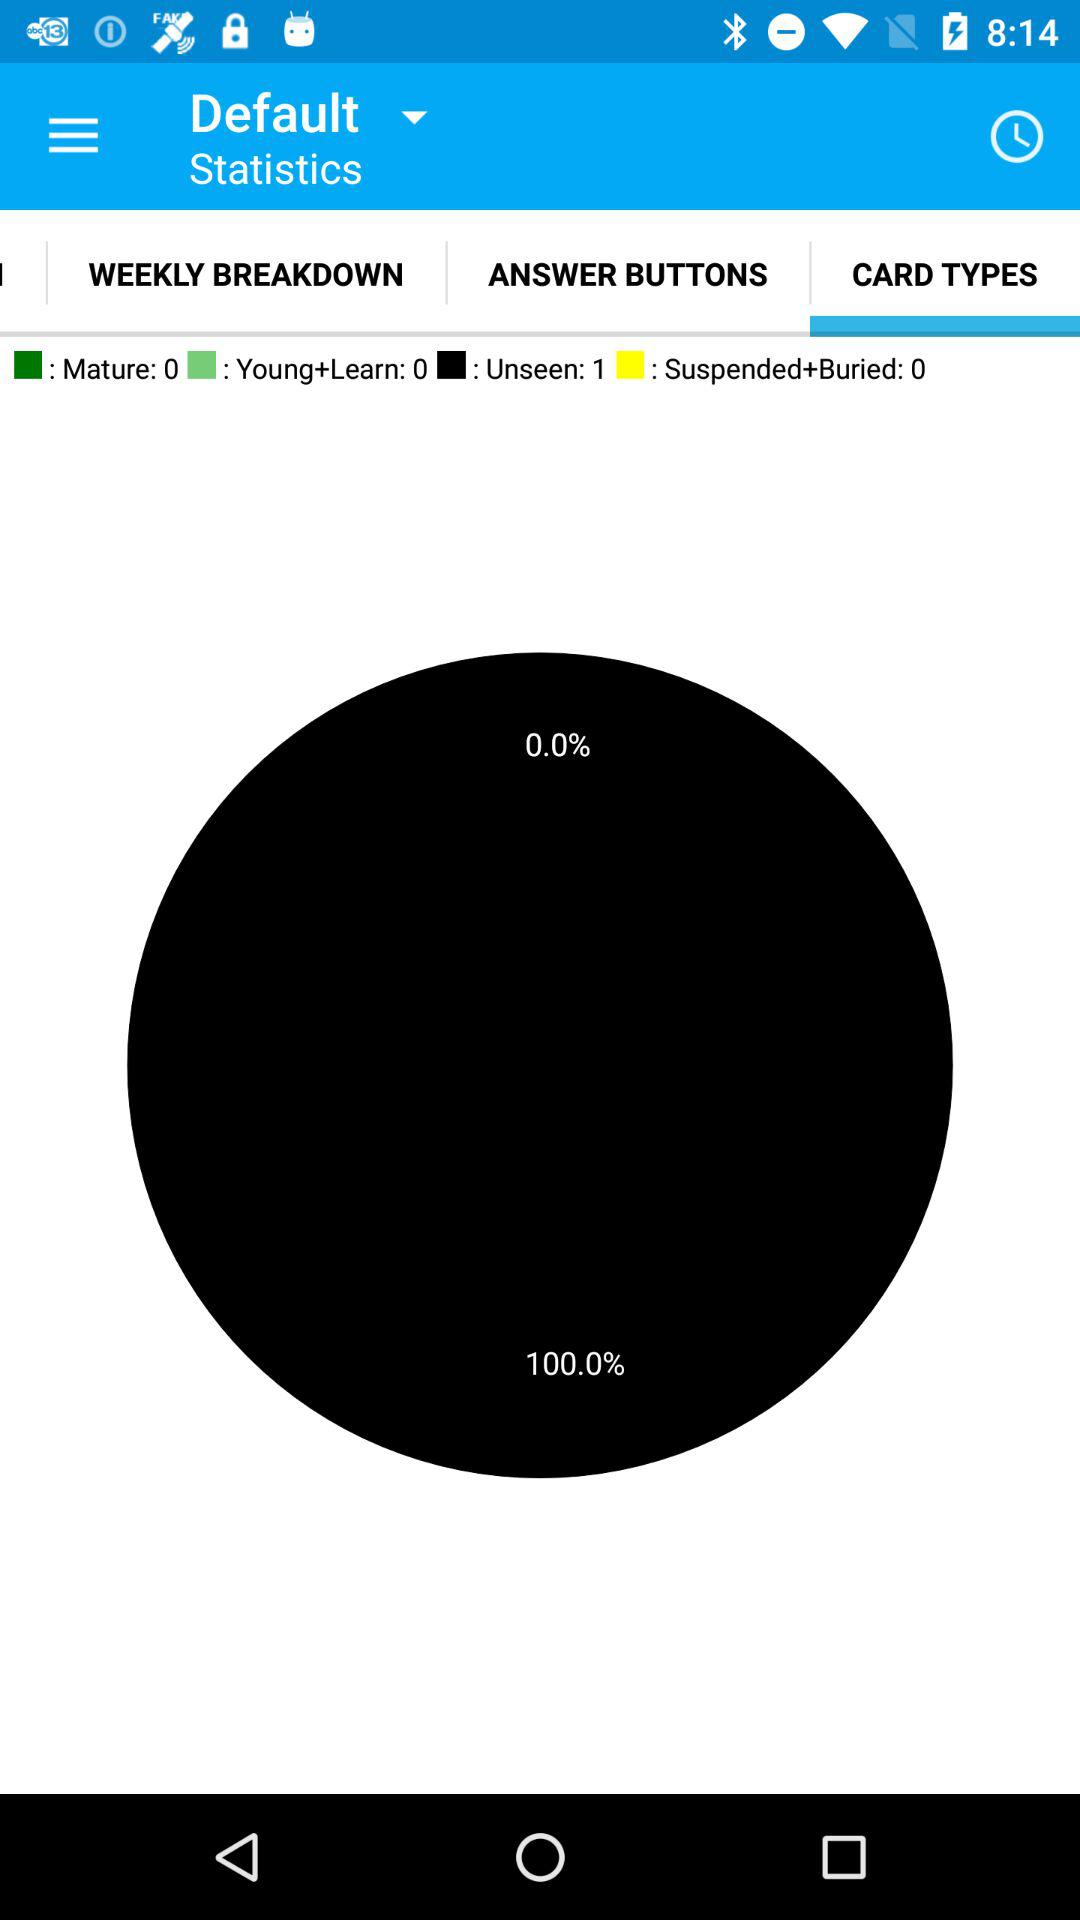What are the statistics for the "Unseen"? The statistics for the "Unseen" are 1. 